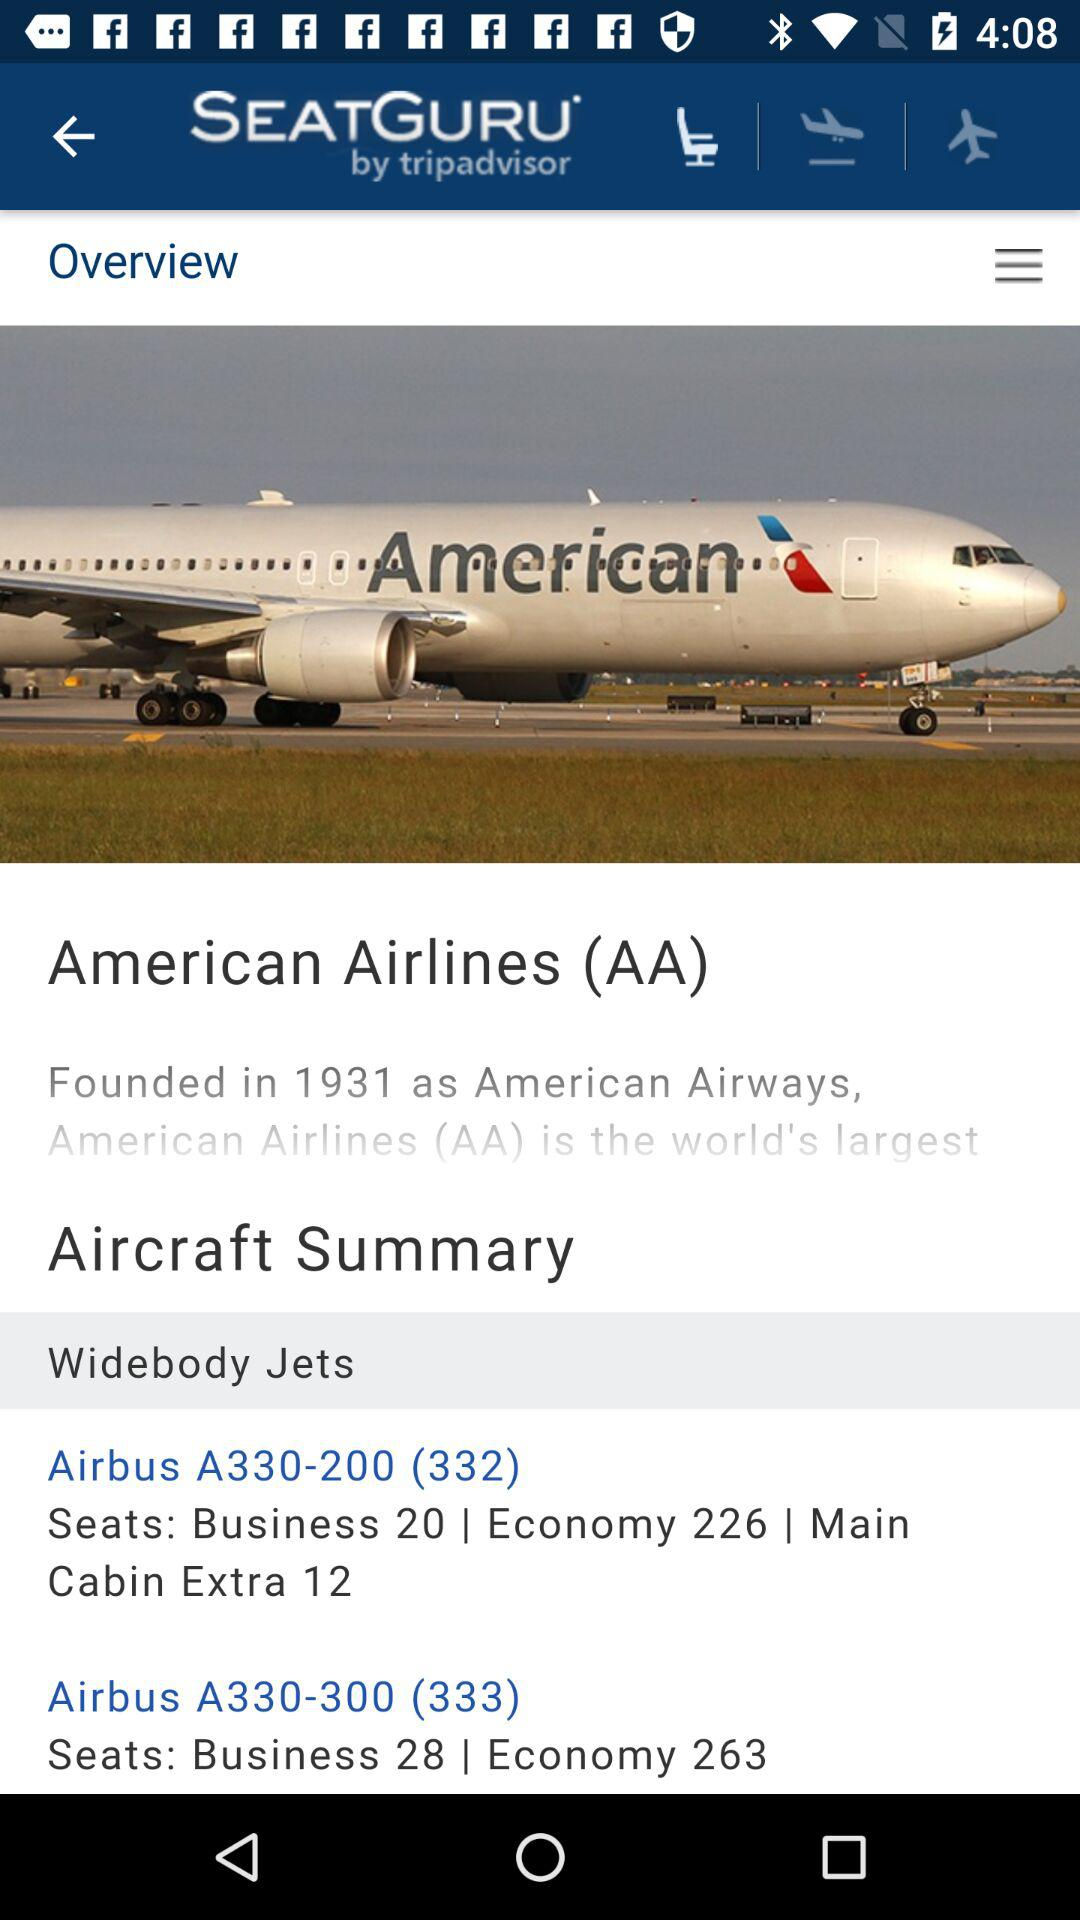What is the name of the application? The name of the application is "SEATGURU by tripadvisor". 